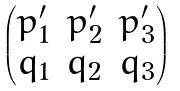Convert formula to latex. <formula><loc_0><loc_0><loc_500><loc_500>\begin{pmatrix} p _ { 1 } ^ { \prime } & p _ { 2 } ^ { \prime } & p _ { 3 } ^ { \prime } \\ q _ { 1 } & q _ { 2 } & q _ { 3 } \end{pmatrix}</formula> 